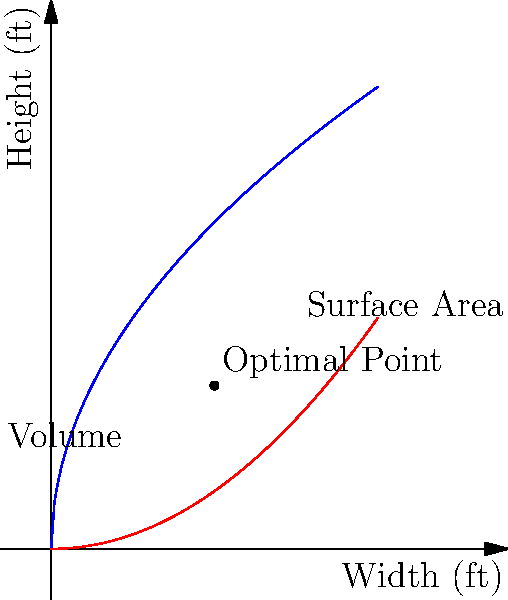As an anesthesiology resident with a love for cats, you're designing an optimal cylindrical cat scratching post. The post should have a volume of 2 cubic feet. Find the dimensions (radius and height) that minimize the surface area of the post, ensuring your feline friends have the most efficient scratching experience. Express your answer in terms of $\sqrt{2}$. Let's approach this step-by-step:

1) Let $r$ be the radius and $h$ be the height of the cylinder.

2) The volume of a cylinder is $V = \pi r^2 h$. We're given that $V = 2$ ft³.
   So, $\pi r^2 h = 2$

3) We can express $h$ in terms of $r$:
   $h = \frac{2}{\pi r^2}$

4) The surface area of a cylinder is $S = 2\pi r^2 + 2\pi rh$

5) Substitute the expression for $h$:
   $S = 2\pi r^2 + 2\pi r(\frac{2}{\pi r^2}) = 2\pi r^2 + \frac{4}{r}$

6) To minimize $S$, we differentiate with respect to $r$ and set it to zero:
   $\frac{dS}{dr} = 4\pi r - \frac{4}{r^2} = 0$

7) Solving this equation:
   $4\pi r = \frac{4}{r^2}$
   $4\pi r^3 = 4$
   $r^3 = \frac{1}{\pi}$
   $r = \frac{1}{\sqrt[3]{\pi}} = \frac{\sqrt[6]{2}}{\sqrt{2}}$

8) To find $h$, we substitute this value of $r$ into the equation from step 3:
   $h = \frac{2}{\pi (\frac{\sqrt[6]{2}}{\sqrt{2}})^2} = \frac{2\sqrt{2}}{\sqrt[3]{2}} = \sqrt{2}$

Therefore, the optimal dimensions are:
Radius $r = \frac{\sqrt[6]{2}}{\sqrt{2}}$ ft
Height $h = \sqrt{2}$ ft

This solution minimizes the surface area while maintaining a volume of 2 cubic feet, providing an efficient scratching post for your cats.
Answer: $r = \frac{\sqrt[6]{2}}{\sqrt{2}}$ ft, $h = \sqrt{2}$ ft 